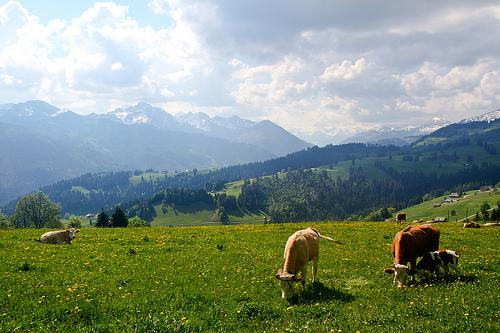Question: what is in the background?
Choices:
A. Cattle.
B. Ocean.
C. Mountains.
D. Canyon.
Answer with the letter. Answer: C Question: why are the cows heads bent down?
Choices:
A. They are eating.
B. They are tired.
C. They are drinking.
D. They are sick.
Answer with the letter. Answer: A Question: what are they eating?
Choices:
A. Grass.
B. Hay.
C. Bugs.
D. Squirells.
Answer with the letter. Answer: A Question: what color are the flowers?
Choices:
A. Yellow.
B. Pink.
C. Orange.
D. White.
Answer with the letter. Answer: A Question: where are the cows?
Choices:
A. In the barn.
B. In the zoo.
C. In a field.
D. In the milking station.
Answer with the letter. Answer: C 